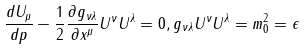Convert formula to latex. <formula><loc_0><loc_0><loc_500><loc_500>\frac { d U _ { \mu } } { d p } - \frac { 1 } { 2 } \frac { \partial g _ { \nu \lambda } } { \partial x ^ { \mu } } U ^ { \nu } U ^ { \lambda } = 0 , g _ { \nu \lambda } U ^ { \nu } U ^ { \lambda } = m _ { 0 } ^ { 2 } = \epsilon</formula> 